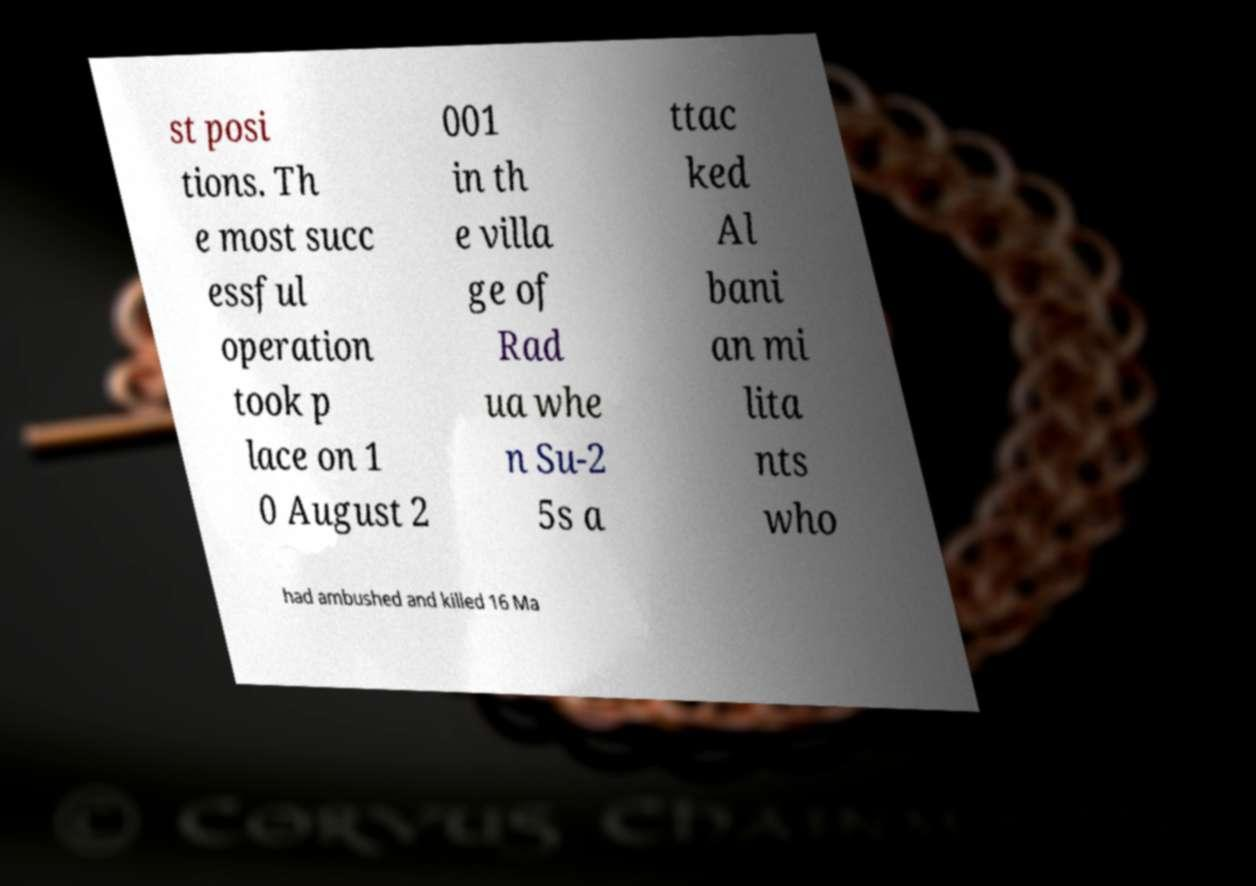I need the written content from this picture converted into text. Can you do that? st posi tions. Th e most succ essful operation took p lace on 1 0 August 2 001 in th e villa ge of Rad ua whe n Su-2 5s a ttac ked Al bani an mi lita nts who had ambushed and killed 16 Ma 